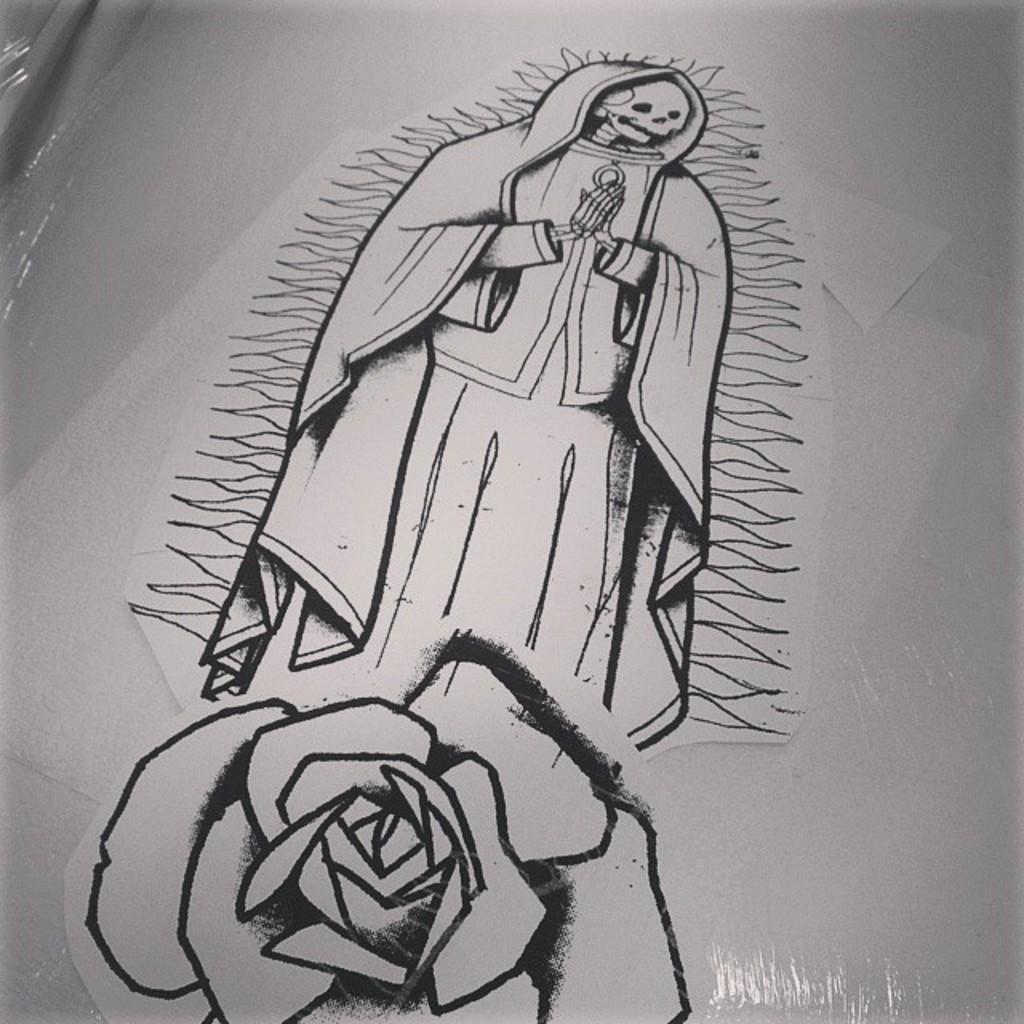Please provide a concise description of this image. In this image, we can see some sketch on a white colored object. We can also see some cover. 